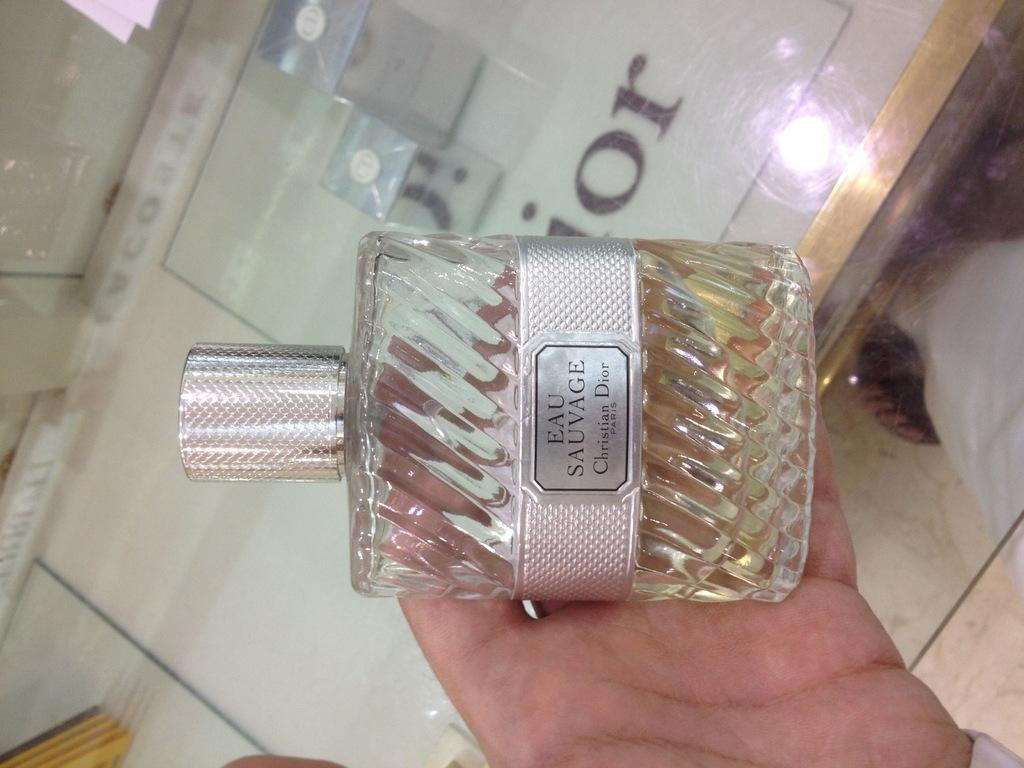What can be seen in the image? There is a hand in the image. What is the hand holding? The hand is holding a perfume bottle. Is there any text or label on the perfume bottle? Yes, there is writing on the perfume bottle. What type of curtain is hanging in the background of the image? There is no curtain present in the image; it only features a hand holding a perfume bottle. 